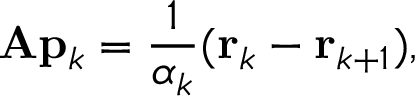<formula> <loc_0><loc_0><loc_500><loc_500>A p _ { k } = { \frac { 1 } { \alpha _ { k } } } ( r _ { k } - r _ { k + 1 } ) ,</formula> 